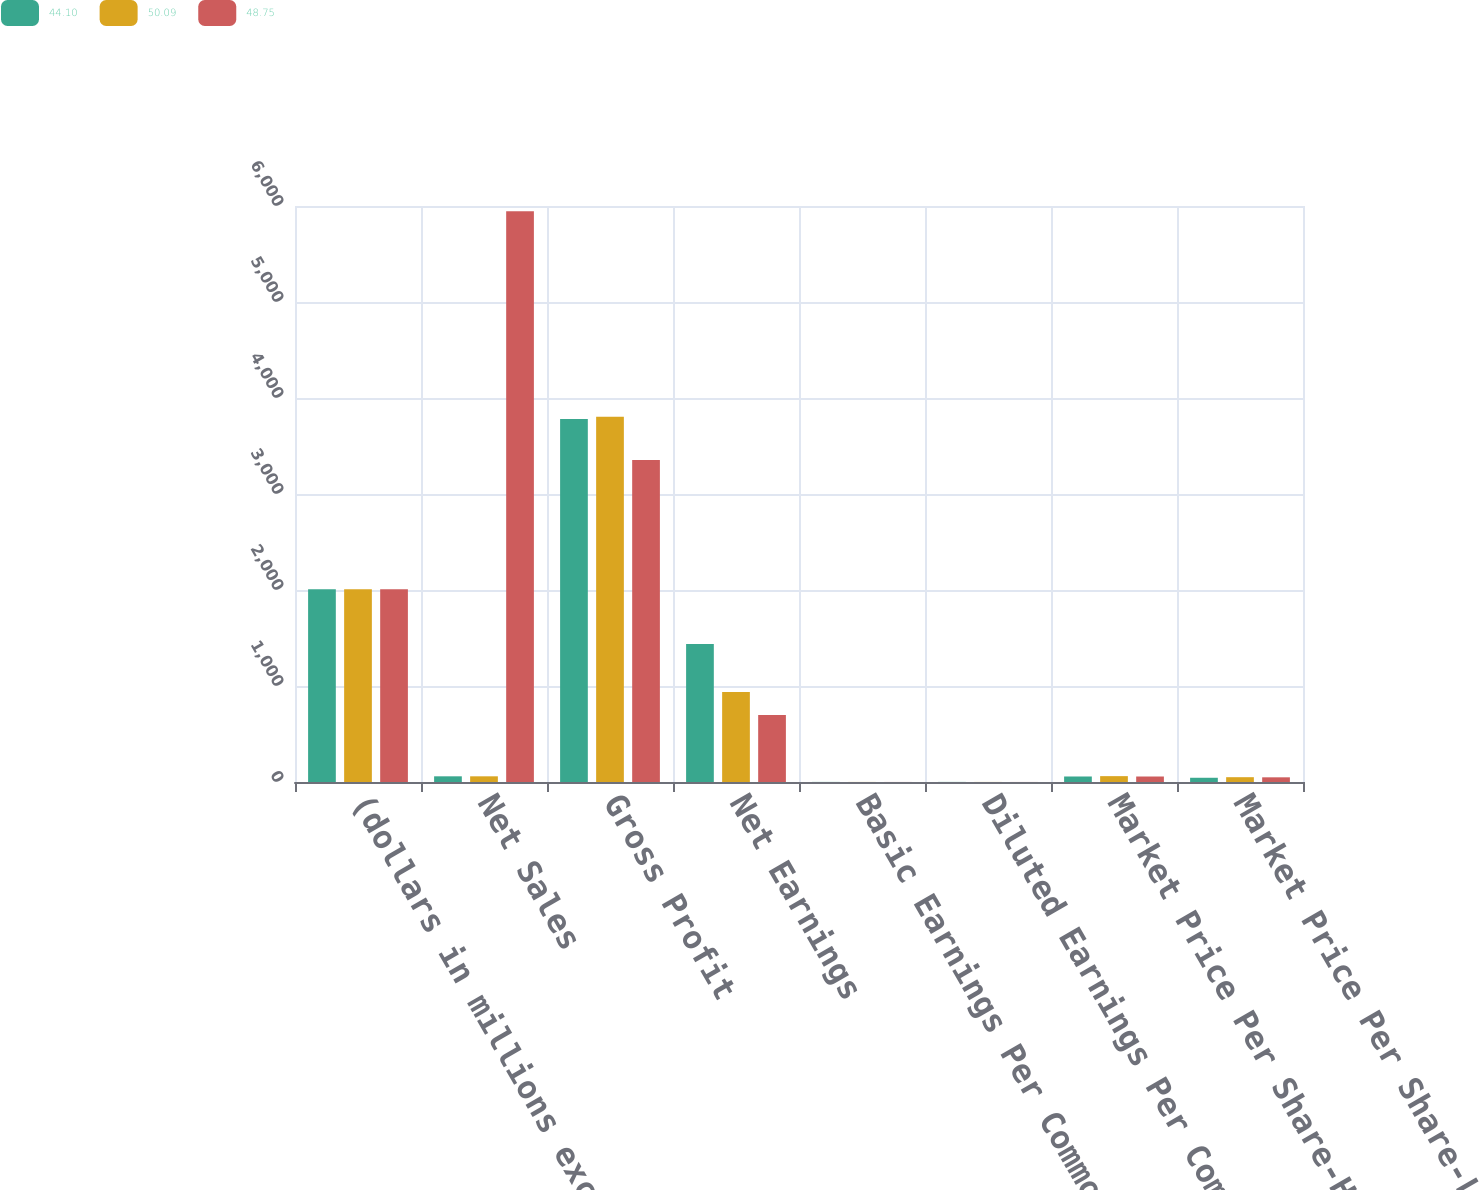<chart> <loc_0><loc_0><loc_500><loc_500><stacked_bar_chart><ecel><fcel>(dollars in millions except<fcel>Net Sales<fcel>Gross Profit<fcel>Net Earnings<fcel>Basic Earnings Per Common<fcel>Diluted Earnings Per Common<fcel>Market Price Per Share-High<fcel>Market Price Per Share-Low<nl><fcel>44.1<fcel>2009<fcel>59.24<fcel>3782.4<fcel>1438.6<fcel>0.93<fcel>0.92<fcel>57.39<fcel>44.1<nl><fcel>50.09<fcel>2008<fcel>59.24<fcel>3804.5<fcel>937.9<fcel>0.61<fcel>0.6<fcel>61.09<fcel>50.09<nl><fcel>48.75<fcel>2007<fcel>5945.5<fcel>3353.5<fcel>697.6<fcel>0.45<fcel>0.45<fcel>57.26<fcel>48.75<nl></chart> 